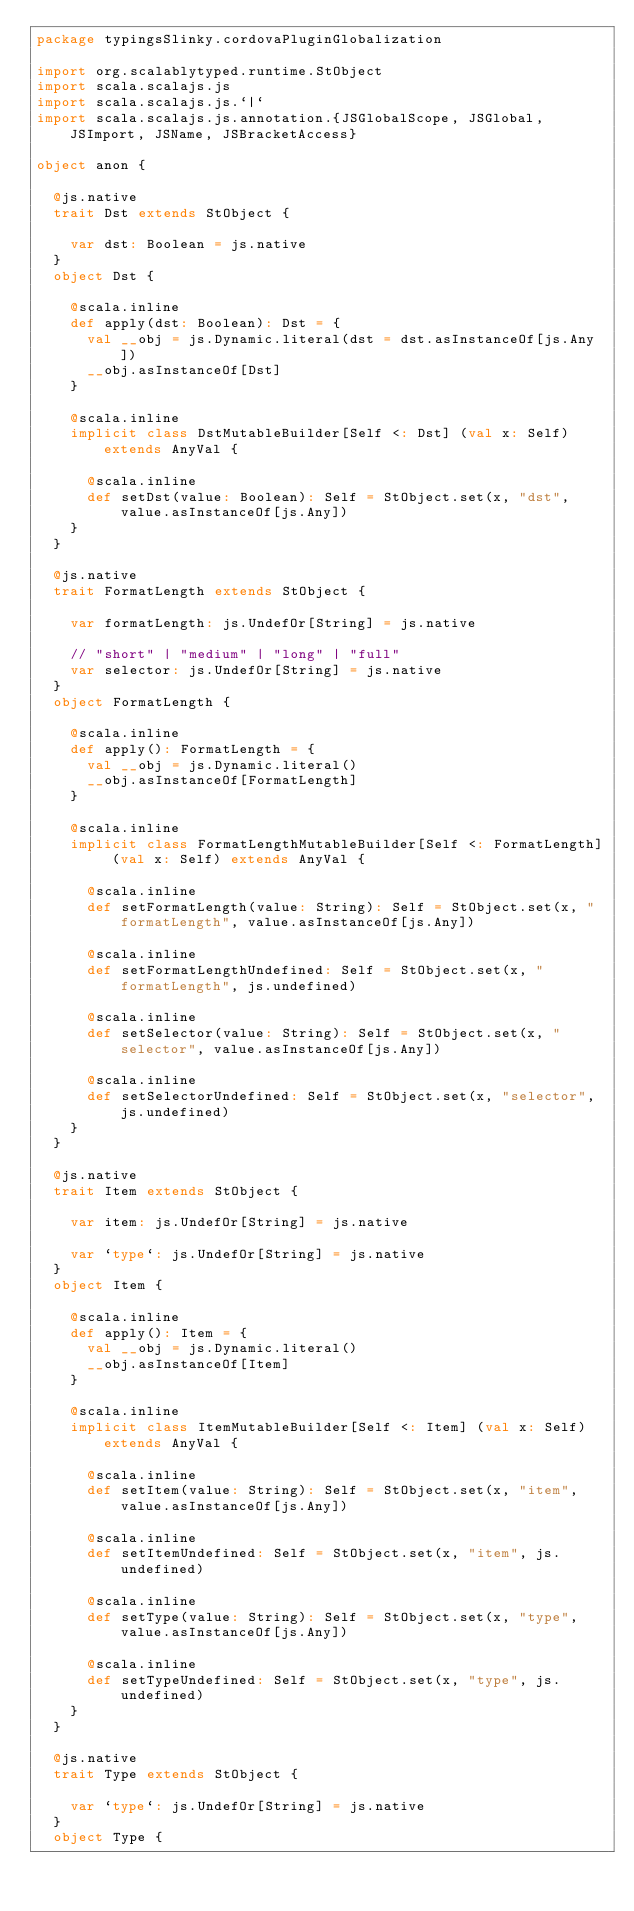<code> <loc_0><loc_0><loc_500><loc_500><_Scala_>package typingsSlinky.cordovaPluginGlobalization

import org.scalablytyped.runtime.StObject
import scala.scalajs.js
import scala.scalajs.js.`|`
import scala.scalajs.js.annotation.{JSGlobalScope, JSGlobal, JSImport, JSName, JSBracketAccess}

object anon {
  
  @js.native
  trait Dst extends StObject {
    
    var dst: Boolean = js.native
  }
  object Dst {
    
    @scala.inline
    def apply(dst: Boolean): Dst = {
      val __obj = js.Dynamic.literal(dst = dst.asInstanceOf[js.Any])
      __obj.asInstanceOf[Dst]
    }
    
    @scala.inline
    implicit class DstMutableBuilder[Self <: Dst] (val x: Self) extends AnyVal {
      
      @scala.inline
      def setDst(value: Boolean): Self = StObject.set(x, "dst", value.asInstanceOf[js.Any])
    }
  }
  
  @js.native
  trait FormatLength extends StObject {
    
    var formatLength: js.UndefOr[String] = js.native
    
    // "short" | "medium" | "long" | "full"
    var selector: js.UndefOr[String] = js.native
  }
  object FormatLength {
    
    @scala.inline
    def apply(): FormatLength = {
      val __obj = js.Dynamic.literal()
      __obj.asInstanceOf[FormatLength]
    }
    
    @scala.inline
    implicit class FormatLengthMutableBuilder[Self <: FormatLength] (val x: Self) extends AnyVal {
      
      @scala.inline
      def setFormatLength(value: String): Self = StObject.set(x, "formatLength", value.asInstanceOf[js.Any])
      
      @scala.inline
      def setFormatLengthUndefined: Self = StObject.set(x, "formatLength", js.undefined)
      
      @scala.inline
      def setSelector(value: String): Self = StObject.set(x, "selector", value.asInstanceOf[js.Any])
      
      @scala.inline
      def setSelectorUndefined: Self = StObject.set(x, "selector", js.undefined)
    }
  }
  
  @js.native
  trait Item extends StObject {
    
    var item: js.UndefOr[String] = js.native
    
    var `type`: js.UndefOr[String] = js.native
  }
  object Item {
    
    @scala.inline
    def apply(): Item = {
      val __obj = js.Dynamic.literal()
      __obj.asInstanceOf[Item]
    }
    
    @scala.inline
    implicit class ItemMutableBuilder[Self <: Item] (val x: Self) extends AnyVal {
      
      @scala.inline
      def setItem(value: String): Self = StObject.set(x, "item", value.asInstanceOf[js.Any])
      
      @scala.inline
      def setItemUndefined: Self = StObject.set(x, "item", js.undefined)
      
      @scala.inline
      def setType(value: String): Self = StObject.set(x, "type", value.asInstanceOf[js.Any])
      
      @scala.inline
      def setTypeUndefined: Self = StObject.set(x, "type", js.undefined)
    }
  }
  
  @js.native
  trait Type extends StObject {
    
    var `type`: js.UndefOr[String] = js.native
  }
  object Type {
    </code> 